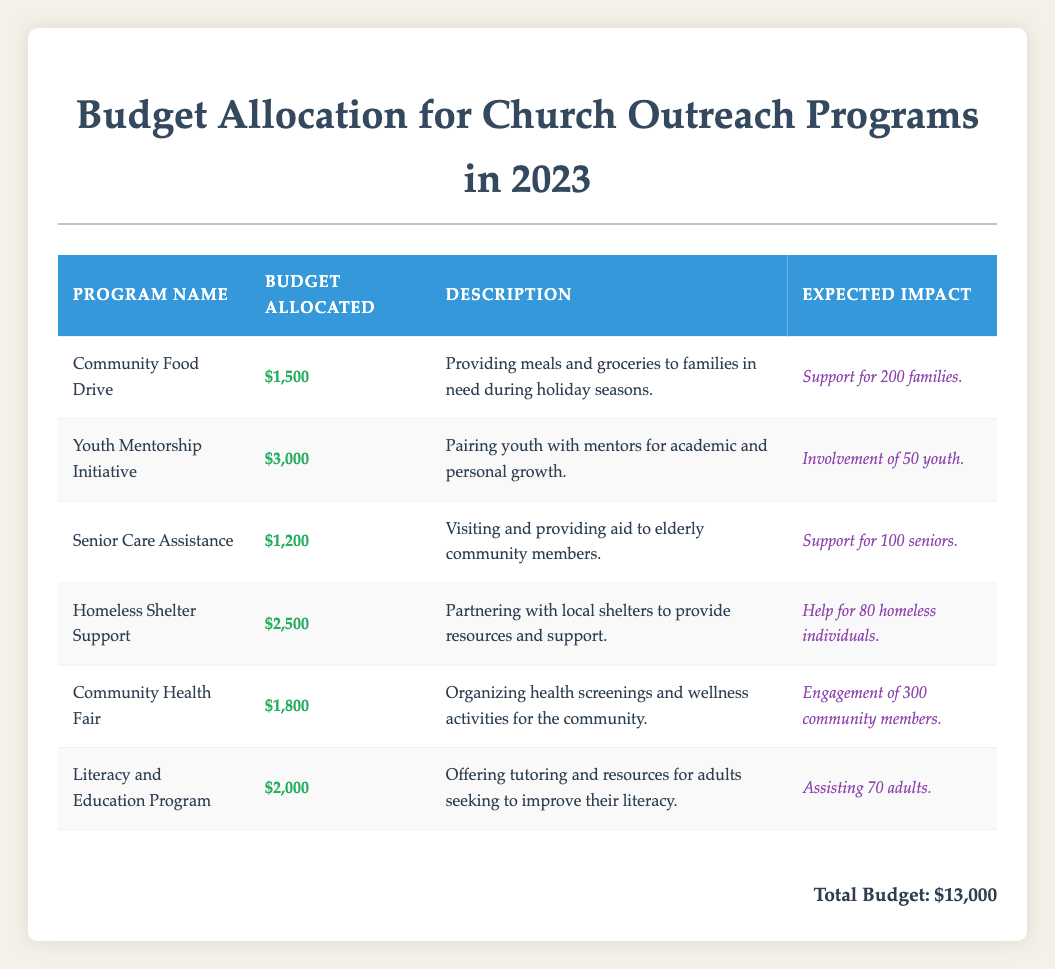What is the budget allocated for the "Youth Mentorship Initiative"? The table shows that the "Youth Mentorship Initiative" has a budget allocated of $3,000.
Answer: $3,000 Which outreach program supports the most families? The "Community Food Drive" is expected to support 200 families, which is the highest among all listed programs.
Answer: Community Food Drive What is the total budget allocation for all outreach programs? The total budget for all outreach programs listed in the table sums up to $13,000 as stated.
Answer: $13,000 Is there an outreach program aimed at assisting seniors? Yes, the "Senior Care Assistance" program is specifically designed to provide aid to elderly community members.
Answer: Yes How much budget is allocated for the "Homeless Shelter Support" program compared to the "Senior Care Assistance" program? The "Homeless Shelter Support" has a budget of $2,500 while the "Senior Care Assistance" has $1,200; the difference is $2,500 - $1,200 = $1,300.
Answer: $1,300 What is the average budget allocated for the six outreach programs? To find the average, sum the budgets ($1,500 + $3,000 + $1,200 + $2,500 + $1,800 + $2,000 = $13,000) and divide by the number of programs (6), which gives $13,000 / 6 = $2,166.67.
Answer: $2,166.67 Which outreach program has the highest expected community engagement? The "Community Health Fair" expects to engage 300 community members, the highest of all the programs listed.
Answer: Community Health Fair What is the combined budget allocated to the "Community Food Drive" and "Literacy and Education Program"? The budget for the "Community Food Drive" is $1,500 and for the "Literacy and Education Program" it is $2,000, thus their combined total is $1,500 + $2,000 = $3,500.
Answer: $3,500 Does any program focus on health awareness? Yes, the "Community Health Fair" is focused on organizing health screenings and wellness activities, thus promoting health awareness.
Answer: Yes If we removed the "Youth Mentorship Initiative" budget from the total, what would the new total be? The total budget is $13,000, and the budget for the "Youth Mentorship Initiative" is $3,000, so the new total would be $13,000 - $3,000 = $10,000.
Answer: $10,000 